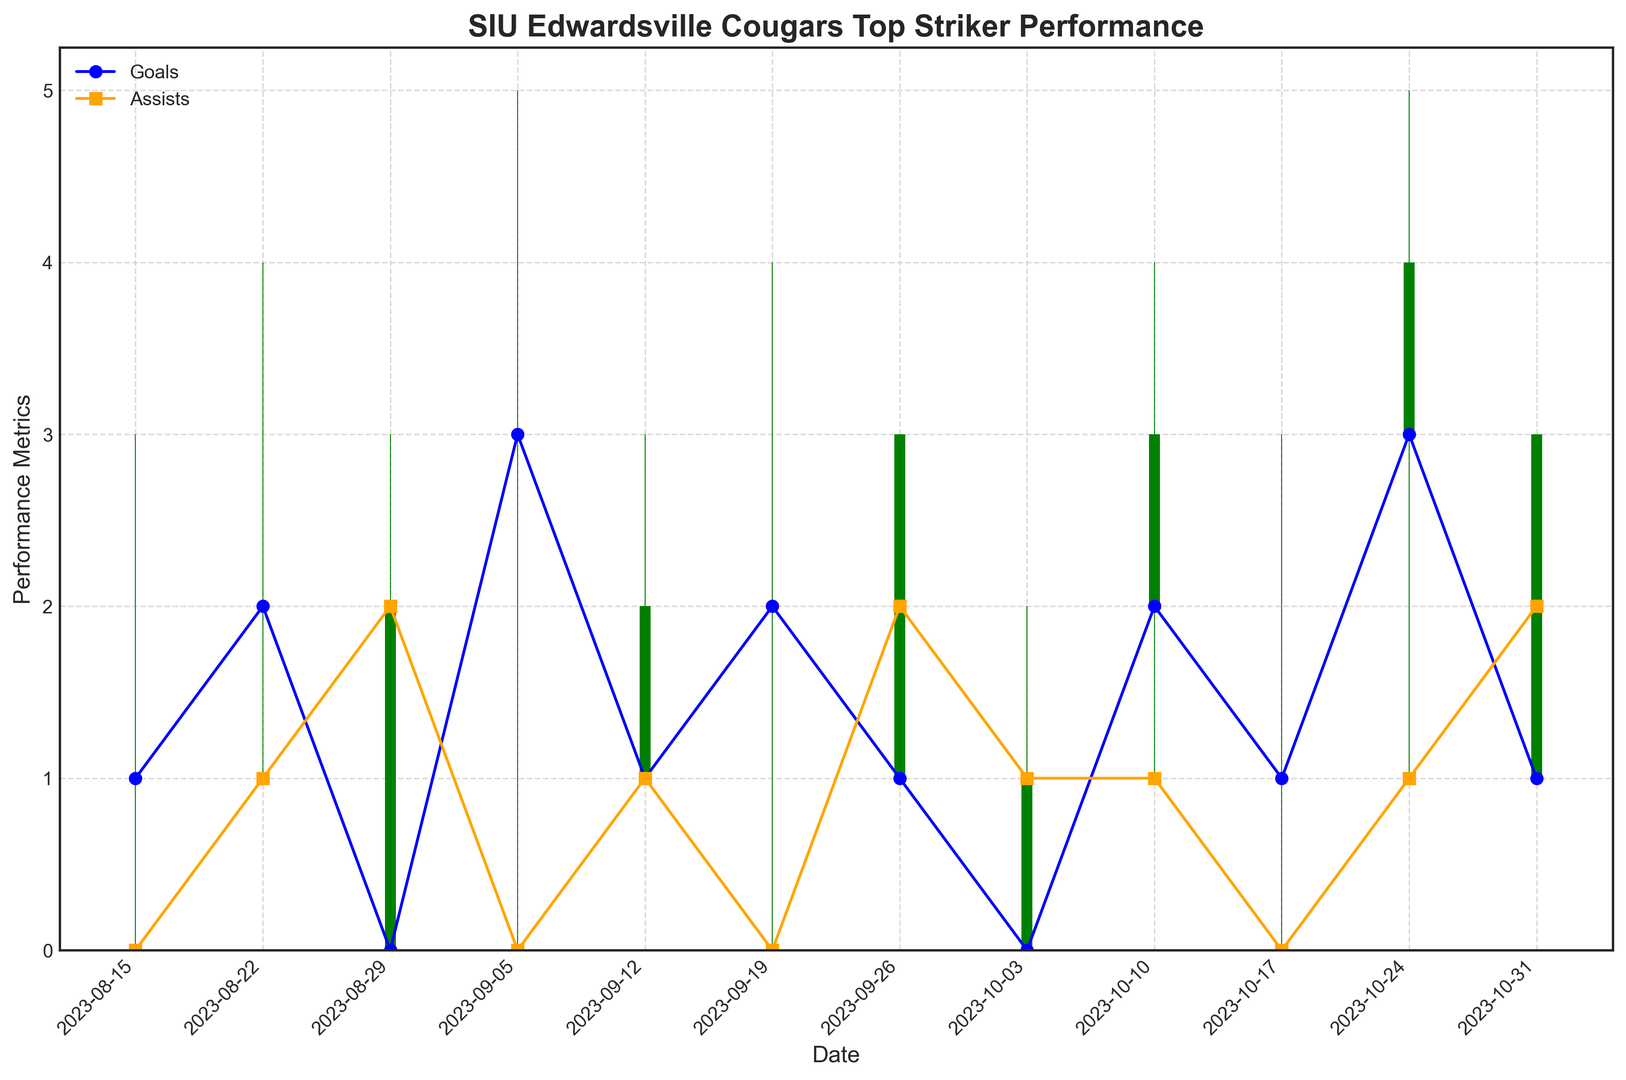What was the highest number of goals scored in a single game? To find this, we look at the 'Goals' plot in the figure. The highest point indicates the maximum number of goals scored in a single game.
Answer: 3 How many games did the player score 2 or more goals? Look for points in the 'Goals' plot that are at 2 or higher. Count these points.
Answer: 5 What's the difference in the number of goals scored between 2023-08-22 and 2023-08-29? From the plot, the number of goals on these dates is 2 and 0 respectively. Calculate the difference: 2 - 0.
Answer: 2 During which game did the player have the highest number of assists? Identify the highest point in the 'Assists' plot. Look for the corresponding date.
Answer: 2023-08-29 In which game did the player have the same number of goals and assists? Locate points where the 'Goals' and 'Assists' plots intersect at the same value. Check the corresponding dates.
Answer: 2023-10-31 Which game had the most balanced performance based on close and open values in the candlestick chart? Look for the candlesticks where the height difference between open and close values is minimal. Identify the corresponding date.
Answer: 2023-09-12 On which date did the player have the least shots on target? Locate the lowest points on the 'Shots on Target' plot and identify the corresponding dates.
Answer: 2023-09-29 and 2023-10-03 How many total fouls did the player commit during the entire period? Add the values from the 'Fouls' column across all dates: 2+1+3+2+1+2+1+2+3+1+2+1.
Answer: 21 Which date had a green candlestick with the largest range (difference between high and low)? Look for the tallest green candlestick in the chart and identify the corresponding date.
Answer: 2023-10-24 Between which two consecutive dates did the number of assists increase the most? Compare the differences in 'Assists' between each pair of consecutive dates. Identify the pair with the maximum increase.
Answer: 2023-08-15 and 2023-08-29 